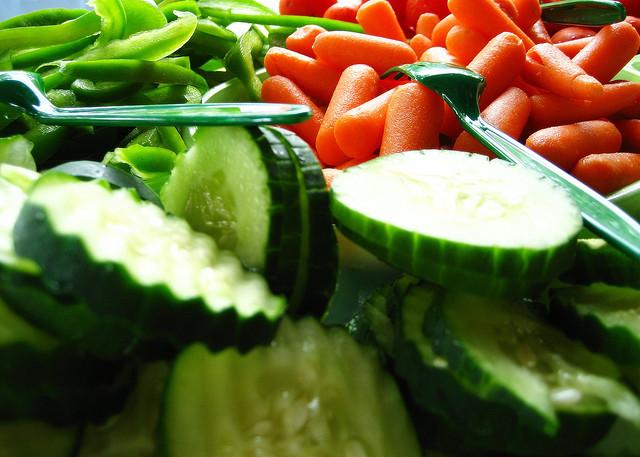How many forks are there?
Give a very brief answer. 2. What vegetables is this?
Quick response, please. Cucumber. Are the vegetables chopped or sliced?
Concise answer only. Sliced. 